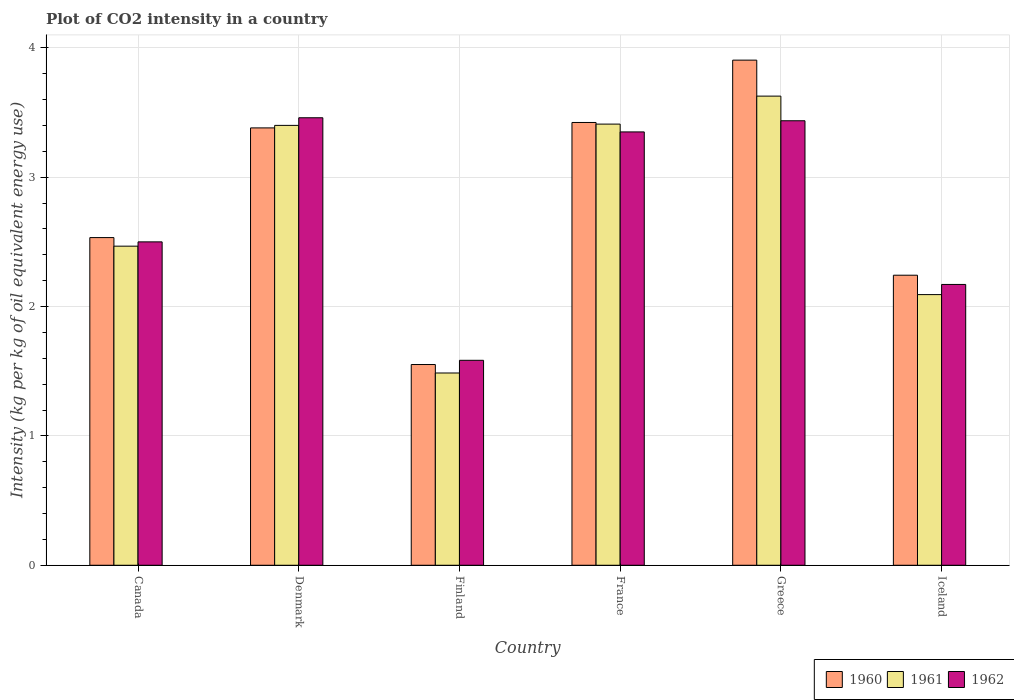How many groups of bars are there?
Your answer should be very brief. 6. Are the number of bars per tick equal to the number of legend labels?
Provide a short and direct response. Yes. What is the CO2 intensity in in 1960 in Canada?
Your answer should be compact. 2.53. Across all countries, what is the maximum CO2 intensity in in 1960?
Keep it short and to the point. 3.91. Across all countries, what is the minimum CO2 intensity in in 1960?
Offer a terse response. 1.55. In which country was the CO2 intensity in in 1962 minimum?
Provide a short and direct response. Finland. What is the total CO2 intensity in in 1961 in the graph?
Offer a very short reply. 16.49. What is the difference between the CO2 intensity in in 1961 in Finland and that in France?
Your response must be concise. -1.92. What is the difference between the CO2 intensity in in 1960 in Canada and the CO2 intensity in in 1961 in Denmark?
Keep it short and to the point. -0.87. What is the average CO2 intensity in in 1962 per country?
Your answer should be compact. 2.75. What is the difference between the CO2 intensity in of/in 1962 and CO2 intensity in of/in 1961 in Canada?
Provide a succinct answer. 0.03. What is the ratio of the CO2 intensity in in 1960 in Finland to that in Iceland?
Offer a very short reply. 0.69. What is the difference between the highest and the second highest CO2 intensity in in 1962?
Ensure brevity in your answer.  -0.02. What is the difference between the highest and the lowest CO2 intensity in in 1962?
Offer a very short reply. 1.88. In how many countries, is the CO2 intensity in in 1962 greater than the average CO2 intensity in in 1962 taken over all countries?
Provide a succinct answer. 3. Is the sum of the CO2 intensity in in 1961 in Denmark and Greece greater than the maximum CO2 intensity in in 1962 across all countries?
Make the answer very short. Yes. What does the 2nd bar from the left in Canada represents?
Your answer should be very brief. 1961. How many countries are there in the graph?
Keep it short and to the point. 6. What is the difference between two consecutive major ticks on the Y-axis?
Your response must be concise. 1. Are the values on the major ticks of Y-axis written in scientific E-notation?
Provide a succinct answer. No. Does the graph contain any zero values?
Your response must be concise. No. Does the graph contain grids?
Your answer should be very brief. Yes. Where does the legend appear in the graph?
Offer a terse response. Bottom right. How many legend labels are there?
Provide a succinct answer. 3. What is the title of the graph?
Your answer should be compact. Plot of CO2 intensity in a country. Does "1981" appear as one of the legend labels in the graph?
Your answer should be very brief. No. What is the label or title of the X-axis?
Offer a very short reply. Country. What is the label or title of the Y-axis?
Ensure brevity in your answer.  Intensity (kg per kg of oil equivalent energy use). What is the Intensity (kg per kg of oil equivalent energy use) of 1960 in Canada?
Your answer should be compact. 2.53. What is the Intensity (kg per kg of oil equivalent energy use) in 1961 in Canada?
Offer a terse response. 2.47. What is the Intensity (kg per kg of oil equivalent energy use) of 1962 in Canada?
Ensure brevity in your answer.  2.5. What is the Intensity (kg per kg of oil equivalent energy use) of 1960 in Denmark?
Offer a very short reply. 3.38. What is the Intensity (kg per kg of oil equivalent energy use) in 1961 in Denmark?
Give a very brief answer. 3.4. What is the Intensity (kg per kg of oil equivalent energy use) of 1962 in Denmark?
Ensure brevity in your answer.  3.46. What is the Intensity (kg per kg of oil equivalent energy use) of 1960 in Finland?
Make the answer very short. 1.55. What is the Intensity (kg per kg of oil equivalent energy use) of 1961 in Finland?
Ensure brevity in your answer.  1.49. What is the Intensity (kg per kg of oil equivalent energy use) in 1962 in Finland?
Offer a very short reply. 1.58. What is the Intensity (kg per kg of oil equivalent energy use) of 1960 in France?
Provide a short and direct response. 3.42. What is the Intensity (kg per kg of oil equivalent energy use) of 1961 in France?
Provide a short and direct response. 3.41. What is the Intensity (kg per kg of oil equivalent energy use) of 1962 in France?
Your answer should be compact. 3.35. What is the Intensity (kg per kg of oil equivalent energy use) in 1960 in Greece?
Provide a short and direct response. 3.91. What is the Intensity (kg per kg of oil equivalent energy use) of 1961 in Greece?
Offer a very short reply. 3.63. What is the Intensity (kg per kg of oil equivalent energy use) in 1962 in Greece?
Offer a very short reply. 3.44. What is the Intensity (kg per kg of oil equivalent energy use) of 1960 in Iceland?
Give a very brief answer. 2.24. What is the Intensity (kg per kg of oil equivalent energy use) in 1961 in Iceland?
Provide a succinct answer. 2.09. What is the Intensity (kg per kg of oil equivalent energy use) in 1962 in Iceland?
Make the answer very short. 2.17. Across all countries, what is the maximum Intensity (kg per kg of oil equivalent energy use) of 1960?
Make the answer very short. 3.91. Across all countries, what is the maximum Intensity (kg per kg of oil equivalent energy use) in 1961?
Make the answer very short. 3.63. Across all countries, what is the maximum Intensity (kg per kg of oil equivalent energy use) of 1962?
Offer a very short reply. 3.46. Across all countries, what is the minimum Intensity (kg per kg of oil equivalent energy use) in 1960?
Ensure brevity in your answer.  1.55. Across all countries, what is the minimum Intensity (kg per kg of oil equivalent energy use) in 1961?
Provide a short and direct response. 1.49. Across all countries, what is the minimum Intensity (kg per kg of oil equivalent energy use) in 1962?
Offer a terse response. 1.58. What is the total Intensity (kg per kg of oil equivalent energy use) of 1960 in the graph?
Your response must be concise. 17.04. What is the total Intensity (kg per kg of oil equivalent energy use) in 1961 in the graph?
Your answer should be very brief. 16.49. What is the total Intensity (kg per kg of oil equivalent energy use) of 1962 in the graph?
Make the answer very short. 16.5. What is the difference between the Intensity (kg per kg of oil equivalent energy use) of 1960 in Canada and that in Denmark?
Your response must be concise. -0.85. What is the difference between the Intensity (kg per kg of oil equivalent energy use) in 1961 in Canada and that in Denmark?
Give a very brief answer. -0.93. What is the difference between the Intensity (kg per kg of oil equivalent energy use) in 1962 in Canada and that in Denmark?
Make the answer very short. -0.96. What is the difference between the Intensity (kg per kg of oil equivalent energy use) in 1960 in Canada and that in Finland?
Offer a very short reply. 0.98. What is the difference between the Intensity (kg per kg of oil equivalent energy use) of 1961 in Canada and that in Finland?
Offer a very short reply. 0.98. What is the difference between the Intensity (kg per kg of oil equivalent energy use) in 1962 in Canada and that in Finland?
Provide a succinct answer. 0.92. What is the difference between the Intensity (kg per kg of oil equivalent energy use) in 1960 in Canada and that in France?
Offer a terse response. -0.89. What is the difference between the Intensity (kg per kg of oil equivalent energy use) in 1961 in Canada and that in France?
Offer a very short reply. -0.94. What is the difference between the Intensity (kg per kg of oil equivalent energy use) in 1962 in Canada and that in France?
Provide a short and direct response. -0.85. What is the difference between the Intensity (kg per kg of oil equivalent energy use) of 1960 in Canada and that in Greece?
Keep it short and to the point. -1.37. What is the difference between the Intensity (kg per kg of oil equivalent energy use) in 1961 in Canada and that in Greece?
Make the answer very short. -1.16. What is the difference between the Intensity (kg per kg of oil equivalent energy use) in 1962 in Canada and that in Greece?
Provide a short and direct response. -0.94. What is the difference between the Intensity (kg per kg of oil equivalent energy use) in 1960 in Canada and that in Iceland?
Ensure brevity in your answer.  0.29. What is the difference between the Intensity (kg per kg of oil equivalent energy use) of 1961 in Canada and that in Iceland?
Offer a very short reply. 0.37. What is the difference between the Intensity (kg per kg of oil equivalent energy use) in 1962 in Canada and that in Iceland?
Make the answer very short. 0.33. What is the difference between the Intensity (kg per kg of oil equivalent energy use) of 1960 in Denmark and that in Finland?
Your answer should be very brief. 1.83. What is the difference between the Intensity (kg per kg of oil equivalent energy use) of 1961 in Denmark and that in Finland?
Provide a short and direct response. 1.91. What is the difference between the Intensity (kg per kg of oil equivalent energy use) of 1962 in Denmark and that in Finland?
Your answer should be compact. 1.88. What is the difference between the Intensity (kg per kg of oil equivalent energy use) in 1960 in Denmark and that in France?
Your answer should be compact. -0.04. What is the difference between the Intensity (kg per kg of oil equivalent energy use) in 1961 in Denmark and that in France?
Offer a terse response. -0.01. What is the difference between the Intensity (kg per kg of oil equivalent energy use) in 1962 in Denmark and that in France?
Provide a succinct answer. 0.11. What is the difference between the Intensity (kg per kg of oil equivalent energy use) in 1960 in Denmark and that in Greece?
Keep it short and to the point. -0.52. What is the difference between the Intensity (kg per kg of oil equivalent energy use) of 1961 in Denmark and that in Greece?
Your response must be concise. -0.23. What is the difference between the Intensity (kg per kg of oil equivalent energy use) in 1962 in Denmark and that in Greece?
Ensure brevity in your answer.  0.02. What is the difference between the Intensity (kg per kg of oil equivalent energy use) of 1960 in Denmark and that in Iceland?
Provide a short and direct response. 1.14. What is the difference between the Intensity (kg per kg of oil equivalent energy use) of 1961 in Denmark and that in Iceland?
Keep it short and to the point. 1.31. What is the difference between the Intensity (kg per kg of oil equivalent energy use) in 1962 in Denmark and that in Iceland?
Provide a short and direct response. 1.29. What is the difference between the Intensity (kg per kg of oil equivalent energy use) of 1960 in Finland and that in France?
Ensure brevity in your answer.  -1.87. What is the difference between the Intensity (kg per kg of oil equivalent energy use) of 1961 in Finland and that in France?
Ensure brevity in your answer.  -1.92. What is the difference between the Intensity (kg per kg of oil equivalent energy use) of 1962 in Finland and that in France?
Make the answer very short. -1.77. What is the difference between the Intensity (kg per kg of oil equivalent energy use) in 1960 in Finland and that in Greece?
Provide a short and direct response. -2.35. What is the difference between the Intensity (kg per kg of oil equivalent energy use) in 1961 in Finland and that in Greece?
Offer a very short reply. -2.14. What is the difference between the Intensity (kg per kg of oil equivalent energy use) in 1962 in Finland and that in Greece?
Provide a short and direct response. -1.85. What is the difference between the Intensity (kg per kg of oil equivalent energy use) in 1960 in Finland and that in Iceland?
Keep it short and to the point. -0.69. What is the difference between the Intensity (kg per kg of oil equivalent energy use) of 1961 in Finland and that in Iceland?
Offer a very short reply. -0.61. What is the difference between the Intensity (kg per kg of oil equivalent energy use) in 1962 in Finland and that in Iceland?
Your answer should be very brief. -0.59. What is the difference between the Intensity (kg per kg of oil equivalent energy use) of 1960 in France and that in Greece?
Offer a terse response. -0.48. What is the difference between the Intensity (kg per kg of oil equivalent energy use) in 1961 in France and that in Greece?
Provide a short and direct response. -0.22. What is the difference between the Intensity (kg per kg of oil equivalent energy use) in 1962 in France and that in Greece?
Your answer should be very brief. -0.09. What is the difference between the Intensity (kg per kg of oil equivalent energy use) of 1960 in France and that in Iceland?
Keep it short and to the point. 1.18. What is the difference between the Intensity (kg per kg of oil equivalent energy use) in 1961 in France and that in Iceland?
Ensure brevity in your answer.  1.32. What is the difference between the Intensity (kg per kg of oil equivalent energy use) in 1962 in France and that in Iceland?
Make the answer very short. 1.18. What is the difference between the Intensity (kg per kg of oil equivalent energy use) in 1960 in Greece and that in Iceland?
Keep it short and to the point. 1.66. What is the difference between the Intensity (kg per kg of oil equivalent energy use) in 1961 in Greece and that in Iceland?
Provide a short and direct response. 1.53. What is the difference between the Intensity (kg per kg of oil equivalent energy use) in 1962 in Greece and that in Iceland?
Give a very brief answer. 1.27. What is the difference between the Intensity (kg per kg of oil equivalent energy use) of 1960 in Canada and the Intensity (kg per kg of oil equivalent energy use) of 1961 in Denmark?
Offer a terse response. -0.87. What is the difference between the Intensity (kg per kg of oil equivalent energy use) of 1960 in Canada and the Intensity (kg per kg of oil equivalent energy use) of 1962 in Denmark?
Ensure brevity in your answer.  -0.93. What is the difference between the Intensity (kg per kg of oil equivalent energy use) in 1961 in Canada and the Intensity (kg per kg of oil equivalent energy use) in 1962 in Denmark?
Provide a succinct answer. -0.99. What is the difference between the Intensity (kg per kg of oil equivalent energy use) of 1960 in Canada and the Intensity (kg per kg of oil equivalent energy use) of 1961 in Finland?
Provide a short and direct response. 1.05. What is the difference between the Intensity (kg per kg of oil equivalent energy use) of 1960 in Canada and the Intensity (kg per kg of oil equivalent energy use) of 1962 in Finland?
Give a very brief answer. 0.95. What is the difference between the Intensity (kg per kg of oil equivalent energy use) of 1961 in Canada and the Intensity (kg per kg of oil equivalent energy use) of 1962 in Finland?
Keep it short and to the point. 0.88. What is the difference between the Intensity (kg per kg of oil equivalent energy use) in 1960 in Canada and the Intensity (kg per kg of oil equivalent energy use) in 1961 in France?
Your answer should be compact. -0.88. What is the difference between the Intensity (kg per kg of oil equivalent energy use) in 1960 in Canada and the Intensity (kg per kg of oil equivalent energy use) in 1962 in France?
Provide a short and direct response. -0.82. What is the difference between the Intensity (kg per kg of oil equivalent energy use) in 1961 in Canada and the Intensity (kg per kg of oil equivalent energy use) in 1962 in France?
Keep it short and to the point. -0.88. What is the difference between the Intensity (kg per kg of oil equivalent energy use) in 1960 in Canada and the Intensity (kg per kg of oil equivalent energy use) in 1961 in Greece?
Offer a very short reply. -1.09. What is the difference between the Intensity (kg per kg of oil equivalent energy use) of 1960 in Canada and the Intensity (kg per kg of oil equivalent energy use) of 1962 in Greece?
Keep it short and to the point. -0.9. What is the difference between the Intensity (kg per kg of oil equivalent energy use) in 1961 in Canada and the Intensity (kg per kg of oil equivalent energy use) in 1962 in Greece?
Offer a very short reply. -0.97. What is the difference between the Intensity (kg per kg of oil equivalent energy use) of 1960 in Canada and the Intensity (kg per kg of oil equivalent energy use) of 1961 in Iceland?
Your answer should be very brief. 0.44. What is the difference between the Intensity (kg per kg of oil equivalent energy use) of 1960 in Canada and the Intensity (kg per kg of oil equivalent energy use) of 1962 in Iceland?
Your response must be concise. 0.36. What is the difference between the Intensity (kg per kg of oil equivalent energy use) of 1961 in Canada and the Intensity (kg per kg of oil equivalent energy use) of 1962 in Iceland?
Keep it short and to the point. 0.3. What is the difference between the Intensity (kg per kg of oil equivalent energy use) in 1960 in Denmark and the Intensity (kg per kg of oil equivalent energy use) in 1961 in Finland?
Keep it short and to the point. 1.9. What is the difference between the Intensity (kg per kg of oil equivalent energy use) in 1960 in Denmark and the Intensity (kg per kg of oil equivalent energy use) in 1962 in Finland?
Ensure brevity in your answer.  1.8. What is the difference between the Intensity (kg per kg of oil equivalent energy use) in 1961 in Denmark and the Intensity (kg per kg of oil equivalent energy use) in 1962 in Finland?
Ensure brevity in your answer.  1.82. What is the difference between the Intensity (kg per kg of oil equivalent energy use) in 1960 in Denmark and the Intensity (kg per kg of oil equivalent energy use) in 1961 in France?
Provide a succinct answer. -0.03. What is the difference between the Intensity (kg per kg of oil equivalent energy use) of 1960 in Denmark and the Intensity (kg per kg of oil equivalent energy use) of 1962 in France?
Provide a succinct answer. 0.03. What is the difference between the Intensity (kg per kg of oil equivalent energy use) of 1961 in Denmark and the Intensity (kg per kg of oil equivalent energy use) of 1962 in France?
Keep it short and to the point. 0.05. What is the difference between the Intensity (kg per kg of oil equivalent energy use) of 1960 in Denmark and the Intensity (kg per kg of oil equivalent energy use) of 1961 in Greece?
Your answer should be very brief. -0.25. What is the difference between the Intensity (kg per kg of oil equivalent energy use) of 1960 in Denmark and the Intensity (kg per kg of oil equivalent energy use) of 1962 in Greece?
Provide a succinct answer. -0.06. What is the difference between the Intensity (kg per kg of oil equivalent energy use) in 1961 in Denmark and the Intensity (kg per kg of oil equivalent energy use) in 1962 in Greece?
Make the answer very short. -0.04. What is the difference between the Intensity (kg per kg of oil equivalent energy use) of 1960 in Denmark and the Intensity (kg per kg of oil equivalent energy use) of 1961 in Iceland?
Your answer should be compact. 1.29. What is the difference between the Intensity (kg per kg of oil equivalent energy use) of 1960 in Denmark and the Intensity (kg per kg of oil equivalent energy use) of 1962 in Iceland?
Your answer should be very brief. 1.21. What is the difference between the Intensity (kg per kg of oil equivalent energy use) in 1961 in Denmark and the Intensity (kg per kg of oil equivalent energy use) in 1962 in Iceland?
Make the answer very short. 1.23. What is the difference between the Intensity (kg per kg of oil equivalent energy use) of 1960 in Finland and the Intensity (kg per kg of oil equivalent energy use) of 1961 in France?
Your response must be concise. -1.86. What is the difference between the Intensity (kg per kg of oil equivalent energy use) of 1960 in Finland and the Intensity (kg per kg of oil equivalent energy use) of 1962 in France?
Offer a terse response. -1.8. What is the difference between the Intensity (kg per kg of oil equivalent energy use) in 1961 in Finland and the Intensity (kg per kg of oil equivalent energy use) in 1962 in France?
Offer a very short reply. -1.86. What is the difference between the Intensity (kg per kg of oil equivalent energy use) in 1960 in Finland and the Intensity (kg per kg of oil equivalent energy use) in 1961 in Greece?
Your answer should be compact. -2.08. What is the difference between the Intensity (kg per kg of oil equivalent energy use) in 1960 in Finland and the Intensity (kg per kg of oil equivalent energy use) in 1962 in Greece?
Offer a terse response. -1.88. What is the difference between the Intensity (kg per kg of oil equivalent energy use) in 1961 in Finland and the Intensity (kg per kg of oil equivalent energy use) in 1962 in Greece?
Provide a short and direct response. -1.95. What is the difference between the Intensity (kg per kg of oil equivalent energy use) of 1960 in Finland and the Intensity (kg per kg of oil equivalent energy use) of 1961 in Iceland?
Provide a succinct answer. -0.54. What is the difference between the Intensity (kg per kg of oil equivalent energy use) in 1960 in Finland and the Intensity (kg per kg of oil equivalent energy use) in 1962 in Iceland?
Keep it short and to the point. -0.62. What is the difference between the Intensity (kg per kg of oil equivalent energy use) of 1961 in Finland and the Intensity (kg per kg of oil equivalent energy use) of 1962 in Iceland?
Offer a very short reply. -0.68. What is the difference between the Intensity (kg per kg of oil equivalent energy use) of 1960 in France and the Intensity (kg per kg of oil equivalent energy use) of 1961 in Greece?
Give a very brief answer. -0.2. What is the difference between the Intensity (kg per kg of oil equivalent energy use) in 1960 in France and the Intensity (kg per kg of oil equivalent energy use) in 1962 in Greece?
Provide a succinct answer. -0.01. What is the difference between the Intensity (kg per kg of oil equivalent energy use) of 1961 in France and the Intensity (kg per kg of oil equivalent energy use) of 1962 in Greece?
Provide a short and direct response. -0.03. What is the difference between the Intensity (kg per kg of oil equivalent energy use) of 1960 in France and the Intensity (kg per kg of oil equivalent energy use) of 1961 in Iceland?
Give a very brief answer. 1.33. What is the difference between the Intensity (kg per kg of oil equivalent energy use) in 1960 in France and the Intensity (kg per kg of oil equivalent energy use) in 1962 in Iceland?
Ensure brevity in your answer.  1.25. What is the difference between the Intensity (kg per kg of oil equivalent energy use) of 1961 in France and the Intensity (kg per kg of oil equivalent energy use) of 1962 in Iceland?
Offer a terse response. 1.24. What is the difference between the Intensity (kg per kg of oil equivalent energy use) in 1960 in Greece and the Intensity (kg per kg of oil equivalent energy use) in 1961 in Iceland?
Provide a short and direct response. 1.81. What is the difference between the Intensity (kg per kg of oil equivalent energy use) of 1960 in Greece and the Intensity (kg per kg of oil equivalent energy use) of 1962 in Iceland?
Offer a terse response. 1.73. What is the difference between the Intensity (kg per kg of oil equivalent energy use) of 1961 in Greece and the Intensity (kg per kg of oil equivalent energy use) of 1962 in Iceland?
Your answer should be compact. 1.46. What is the average Intensity (kg per kg of oil equivalent energy use) of 1960 per country?
Keep it short and to the point. 2.84. What is the average Intensity (kg per kg of oil equivalent energy use) in 1961 per country?
Offer a terse response. 2.75. What is the average Intensity (kg per kg of oil equivalent energy use) of 1962 per country?
Ensure brevity in your answer.  2.75. What is the difference between the Intensity (kg per kg of oil equivalent energy use) of 1960 and Intensity (kg per kg of oil equivalent energy use) of 1961 in Canada?
Ensure brevity in your answer.  0.07. What is the difference between the Intensity (kg per kg of oil equivalent energy use) in 1960 and Intensity (kg per kg of oil equivalent energy use) in 1962 in Canada?
Provide a short and direct response. 0.03. What is the difference between the Intensity (kg per kg of oil equivalent energy use) of 1961 and Intensity (kg per kg of oil equivalent energy use) of 1962 in Canada?
Offer a terse response. -0.03. What is the difference between the Intensity (kg per kg of oil equivalent energy use) in 1960 and Intensity (kg per kg of oil equivalent energy use) in 1961 in Denmark?
Your response must be concise. -0.02. What is the difference between the Intensity (kg per kg of oil equivalent energy use) in 1960 and Intensity (kg per kg of oil equivalent energy use) in 1962 in Denmark?
Your answer should be compact. -0.08. What is the difference between the Intensity (kg per kg of oil equivalent energy use) in 1961 and Intensity (kg per kg of oil equivalent energy use) in 1962 in Denmark?
Offer a terse response. -0.06. What is the difference between the Intensity (kg per kg of oil equivalent energy use) in 1960 and Intensity (kg per kg of oil equivalent energy use) in 1961 in Finland?
Give a very brief answer. 0.07. What is the difference between the Intensity (kg per kg of oil equivalent energy use) in 1960 and Intensity (kg per kg of oil equivalent energy use) in 1962 in Finland?
Give a very brief answer. -0.03. What is the difference between the Intensity (kg per kg of oil equivalent energy use) of 1961 and Intensity (kg per kg of oil equivalent energy use) of 1962 in Finland?
Keep it short and to the point. -0.1. What is the difference between the Intensity (kg per kg of oil equivalent energy use) in 1960 and Intensity (kg per kg of oil equivalent energy use) in 1961 in France?
Provide a succinct answer. 0.01. What is the difference between the Intensity (kg per kg of oil equivalent energy use) in 1960 and Intensity (kg per kg of oil equivalent energy use) in 1962 in France?
Offer a very short reply. 0.07. What is the difference between the Intensity (kg per kg of oil equivalent energy use) of 1961 and Intensity (kg per kg of oil equivalent energy use) of 1962 in France?
Ensure brevity in your answer.  0.06. What is the difference between the Intensity (kg per kg of oil equivalent energy use) in 1960 and Intensity (kg per kg of oil equivalent energy use) in 1961 in Greece?
Ensure brevity in your answer.  0.28. What is the difference between the Intensity (kg per kg of oil equivalent energy use) of 1960 and Intensity (kg per kg of oil equivalent energy use) of 1962 in Greece?
Your response must be concise. 0.47. What is the difference between the Intensity (kg per kg of oil equivalent energy use) in 1961 and Intensity (kg per kg of oil equivalent energy use) in 1962 in Greece?
Your answer should be compact. 0.19. What is the difference between the Intensity (kg per kg of oil equivalent energy use) in 1960 and Intensity (kg per kg of oil equivalent energy use) in 1961 in Iceland?
Make the answer very short. 0.15. What is the difference between the Intensity (kg per kg of oil equivalent energy use) of 1960 and Intensity (kg per kg of oil equivalent energy use) of 1962 in Iceland?
Your answer should be very brief. 0.07. What is the difference between the Intensity (kg per kg of oil equivalent energy use) in 1961 and Intensity (kg per kg of oil equivalent energy use) in 1962 in Iceland?
Offer a very short reply. -0.08. What is the ratio of the Intensity (kg per kg of oil equivalent energy use) of 1960 in Canada to that in Denmark?
Provide a succinct answer. 0.75. What is the ratio of the Intensity (kg per kg of oil equivalent energy use) in 1961 in Canada to that in Denmark?
Offer a terse response. 0.73. What is the ratio of the Intensity (kg per kg of oil equivalent energy use) in 1962 in Canada to that in Denmark?
Give a very brief answer. 0.72. What is the ratio of the Intensity (kg per kg of oil equivalent energy use) in 1960 in Canada to that in Finland?
Provide a succinct answer. 1.63. What is the ratio of the Intensity (kg per kg of oil equivalent energy use) of 1961 in Canada to that in Finland?
Provide a short and direct response. 1.66. What is the ratio of the Intensity (kg per kg of oil equivalent energy use) in 1962 in Canada to that in Finland?
Give a very brief answer. 1.58. What is the ratio of the Intensity (kg per kg of oil equivalent energy use) in 1960 in Canada to that in France?
Offer a terse response. 0.74. What is the ratio of the Intensity (kg per kg of oil equivalent energy use) in 1961 in Canada to that in France?
Provide a succinct answer. 0.72. What is the ratio of the Intensity (kg per kg of oil equivalent energy use) in 1962 in Canada to that in France?
Your answer should be compact. 0.75. What is the ratio of the Intensity (kg per kg of oil equivalent energy use) in 1960 in Canada to that in Greece?
Keep it short and to the point. 0.65. What is the ratio of the Intensity (kg per kg of oil equivalent energy use) in 1961 in Canada to that in Greece?
Offer a very short reply. 0.68. What is the ratio of the Intensity (kg per kg of oil equivalent energy use) in 1962 in Canada to that in Greece?
Offer a terse response. 0.73. What is the ratio of the Intensity (kg per kg of oil equivalent energy use) in 1960 in Canada to that in Iceland?
Provide a short and direct response. 1.13. What is the ratio of the Intensity (kg per kg of oil equivalent energy use) in 1961 in Canada to that in Iceland?
Give a very brief answer. 1.18. What is the ratio of the Intensity (kg per kg of oil equivalent energy use) of 1962 in Canada to that in Iceland?
Offer a very short reply. 1.15. What is the ratio of the Intensity (kg per kg of oil equivalent energy use) of 1960 in Denmark to that in Finland?
Your answer should be very brief. 2.18. What is the ratio of the Intensity (kg per kg of oil equivalent energy use) of 1961 in Denmark to that in Finland?
Provide a succinct answer. 2.29. What is the ratio of the Intensity (kg per kg of oil equivalent energy use) in 1962 in Denmark to that in Finland?
Ensure brevity in your answer.  2.18. What is the ratio of the Intensity (kg per kg of oil equivalent energy use) of 1961 in Denmark to that in France?
Make the answer very short. 1. What is the ratio of the Intensity (kg per kg of oil equivalent energy use) of 1962 in Denmark to that in France?
Make the answer very short. 1.03. What is the ratio of the Intensity (kg per kg of oil equivalent energy use) of 1960 in Denmark to that in Greece?
Your answer should be compact. 0.87. What is the ratio of the Intensity (kg per kg of oil equivalent energy use) of 1961 in Denmark to that in Greece?
Provide a succinct answer. 0.94. What is the ratio of the Intensity (kg per kg of oil equivalent energy use) of 1962 in Denmark to that in Greece?
Keep it short and to the point. 1.01. What is the ratio of the Intensity (kg per kg of oil equivalent energy use) of 1960 in Denmark to that in Iceland?
Offer a very short reply. 1.51. What is the ratio of the Intensity (kg per kg of oil equivalent energy use) in 1961 in Denmark to that in Iceland?
Your answer should be very brief. 1.63. What is the ratio of the Intensity (kg per kg of oil equivalent energy use) in 1962 in Denmark to that in Iceland?
Your answer should be very brief. 1.59. What is the ratio of the Intensity (kg per kg of oil equivalent energy use) of 1960 in Finland to that in France?
Give a very brief answer. 0.45. What is the ratio of the Intensity (kg per kg of oil equivalent energy use) in 1961 in Finland to that in France?
Provide a short and direct response. 0.44. What is the ratio of the Intensity (kg per kg of oil equivalent energy use) in 1962 in Finland to that in France?
Offer a terse response. 0.47. What is the ratio of the Intensity (kg per kg of oil equivalent energy use) of 1960 in Finland to that in Greece?
Provide a short and direct response. 0.4. What is the ratio of the Intensity (kg per kg of oil equivalent energy use) in 1961 in Finland to that in Greece?
Your answer should be compact. 0.41. What is the ratio of the Intensity (kg per kg of oil equivalent energy use) of 1962 in Finland to that in Greece?
Keep it short and to the point. 0.46. What is the ratio of the Intensity (kg per kg of oil equivalent energy use) in 1960 in Finland to that in Iceland?
Your response must be concise. 0.69. What is the ratio of the Intensity (kg per kg of oil equivalent energy use) in 1961 in Finland to that in Iceland?
Give a very brief answer. 0.71. What is the ratio of the Intensity (kg per kg of oil equivalent energy use) of 1962 in Finland to that in Iceland?
Offer a terse response. 0.73. What is the ratio of the Intensity (kg per kg of oil equivalent energy use) in 1960 in France to that in Greece?
Make the answer very short. 0.88. What is the ratio of the Intensity (kg per kg of oil equivalent energy use) of 1961 in France to that in Greece?
Your answer should be compact. 0.94. What is the ratio of the Intensity (kg per kg of oil equivalent energy use) of 1962 in France to that in Greece?
Provide a short and direct response. 0.97. What is the ratio of the Intensity (kg per kg of oil equivalent energy use) of 1960 in France to that in Iceland?
Ensure brevity in your answer.  1.53. What is the ratio of the Intensity (kg per kg of oil equivalent energy use) in 1961 in France to that in Iceland?
Provide a succinct answer. 1.63. What is the ratio of the Intensity (kg per kg of oil equivalent energy use) of 1962 in France to that in Iceland?
Offer a very short reply. 1.54. What is the ratio of the Intensity (kg per kg of oil equivalent energy use) in 1960 in Greece to that in Iceland?
Keep it short and to the point. 1.74. What is the ratio of the Intensity (kg per kg of oil equivalent energy use) in 1961 in Greece to that in Iceland?
Offer a terse response. 1.73. What is the ratio of the Intensity (kg per kg of oil equivalent energy use) of 1962 in Greece to that in Iceland?
Provide a succinct answer. 1.58. What is the difference between the highest and the second highest Intensity (kg per kg of oil equivalent energy use) in 1960?
Keep it short and to the point. 0.48. What is the difference between the highest and the second highest Intensity (kg per kg of oil equivalent energy use) of 1961?
Your response must be concise. 0.22. What is the difference between the highest and the second highest Intensity (kg per kg of oil equivalent energy use) of 1962?
Your answer should be very brief. 0.02. What is the difference between the highest and the lowest Intensity (kg per kg of oil equivalent energy use) in 1960?
Your answer should be very brief. 2.35. What is the difference between the highest and the lowest Intensity (kg per kg of oil equivalent energy use) of 1961?
Make the answer very short. 2.14. What is the difference between the highest and the lowest Intensity (kg per kg of oil equivalent energy use) in 1962?
Give a very brief answer. 1.88. 